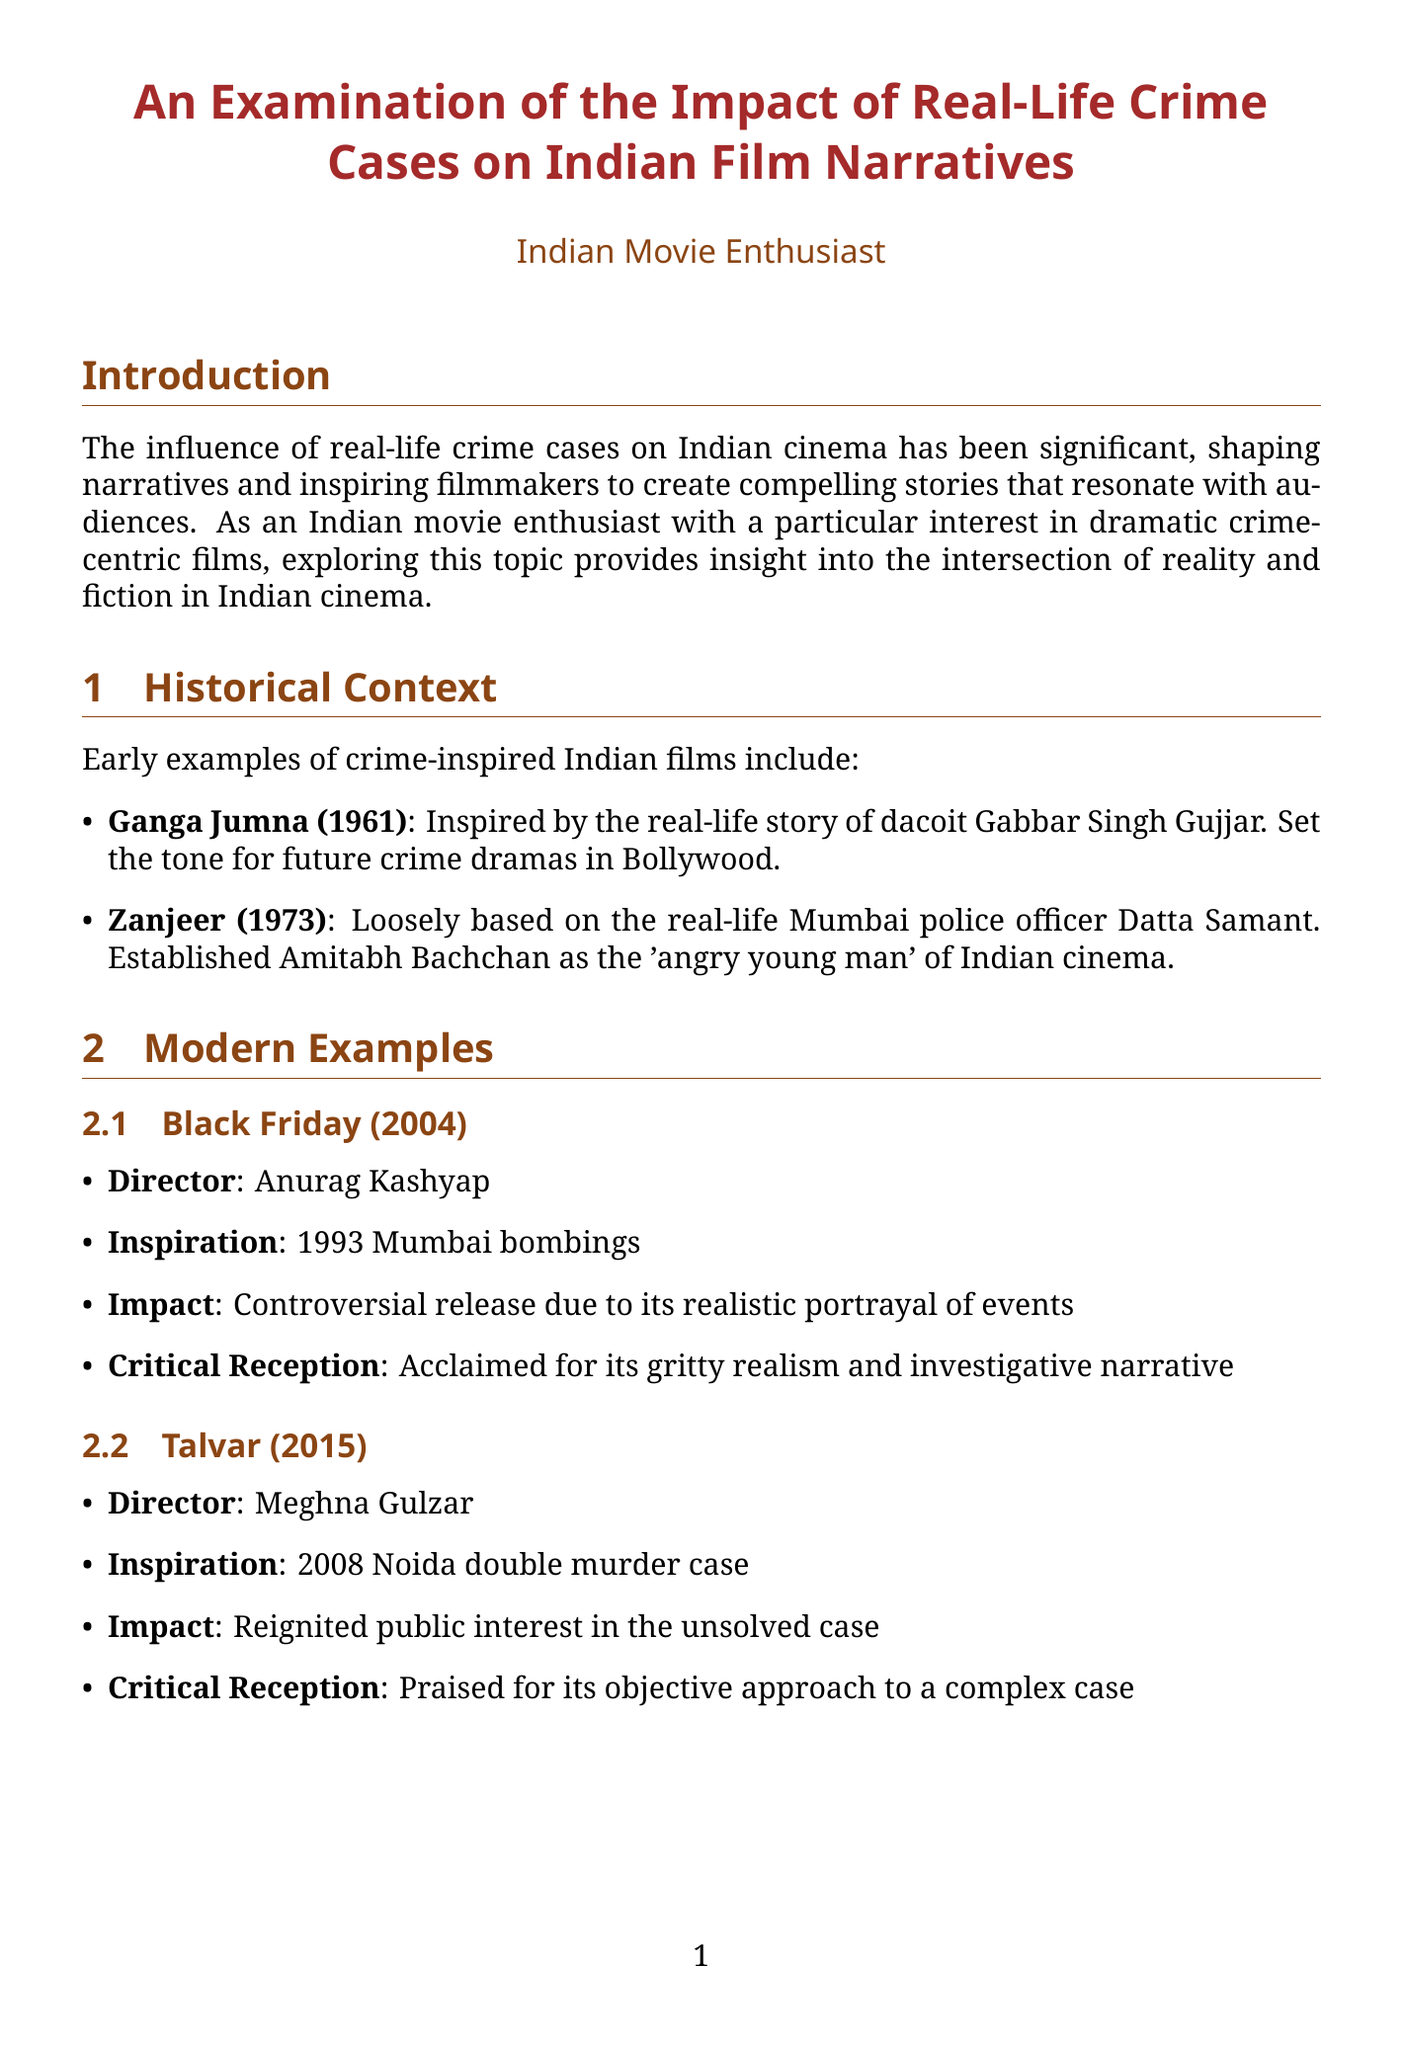What year was "Ganga Jumna" released? "Ganga Jumna" was released in 1961, which can be found in the historical context section of the document.
Answer: 1961 Who directed "Black Friday"? The document lists Anurag Kashyap as the director of "Black Friday".
Answer: Anurag Kashyap What is the impact of "Talvar"? The impact of "Talvar" is that it reignited public interest in the unsolved case, as mentioned in the modern examples section.
Answer: Reignited public interest in the unsolved case Which notable director is known for realistic portrayals of the underworld? The director known for gritty, realistic portrayals of the underworld is Ram Gopal Varma, according to the notable directors section.
Answer: Ram Gopal Varma How have films based on true crimes influenced public awareness? The document states that films based on true crimes have raised public awareness about social issues and legal processes.
Answer: Raised public awareness about social issues and legal processes What trend is mentioned for crime stories in Indian cinema's future? The document mentions a shift towards long-form storytelling through web series platforms as a future trend.
Answer: Shift towards long-form storytelling through web series platforms What is one challenge faced by filmmakers in this genre? The challenges include legal issues and potential defamation suits, as outlined in the challenges faced by filmmakers section.
Answer: Legal issues and potential defamation suits What is a key narrative technique used in modern crime-centric films? The document highlights the increased use of documentary-style filming as a key narrative technique in modern films.
Answer: Increased use of documentary-style filming 